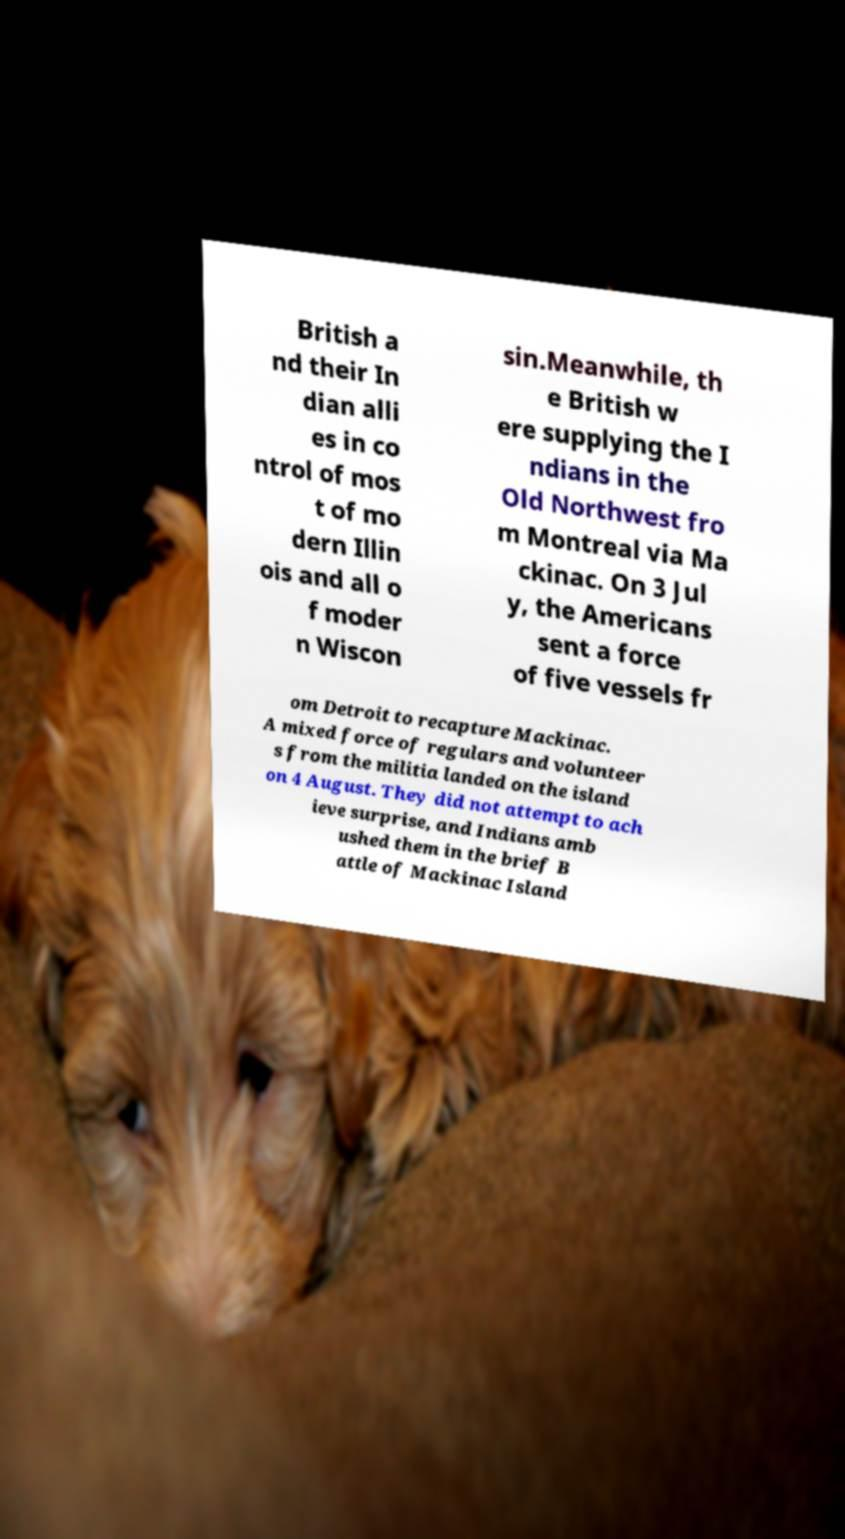Could you extract and type out the text from this image? British a nd their In dian alli es in co ntrol of mos t of mo dern Illin ois and all o f moder n Wiscon sin.Meanwhile, th e British w ere supplying the I ndians in the Old Northwest fro m Montreal via Ma ckinac. On 3 Jul y, the Americans sent a force of five vessels fr om Detroit to recapture Mackinac. A mixed force of regulars and volunteer s from the militia landed on the island on 4 August. They did not attempt to ach ieve surprise, and Indians amb ushed them in the brief B attle of Mackinac Island 